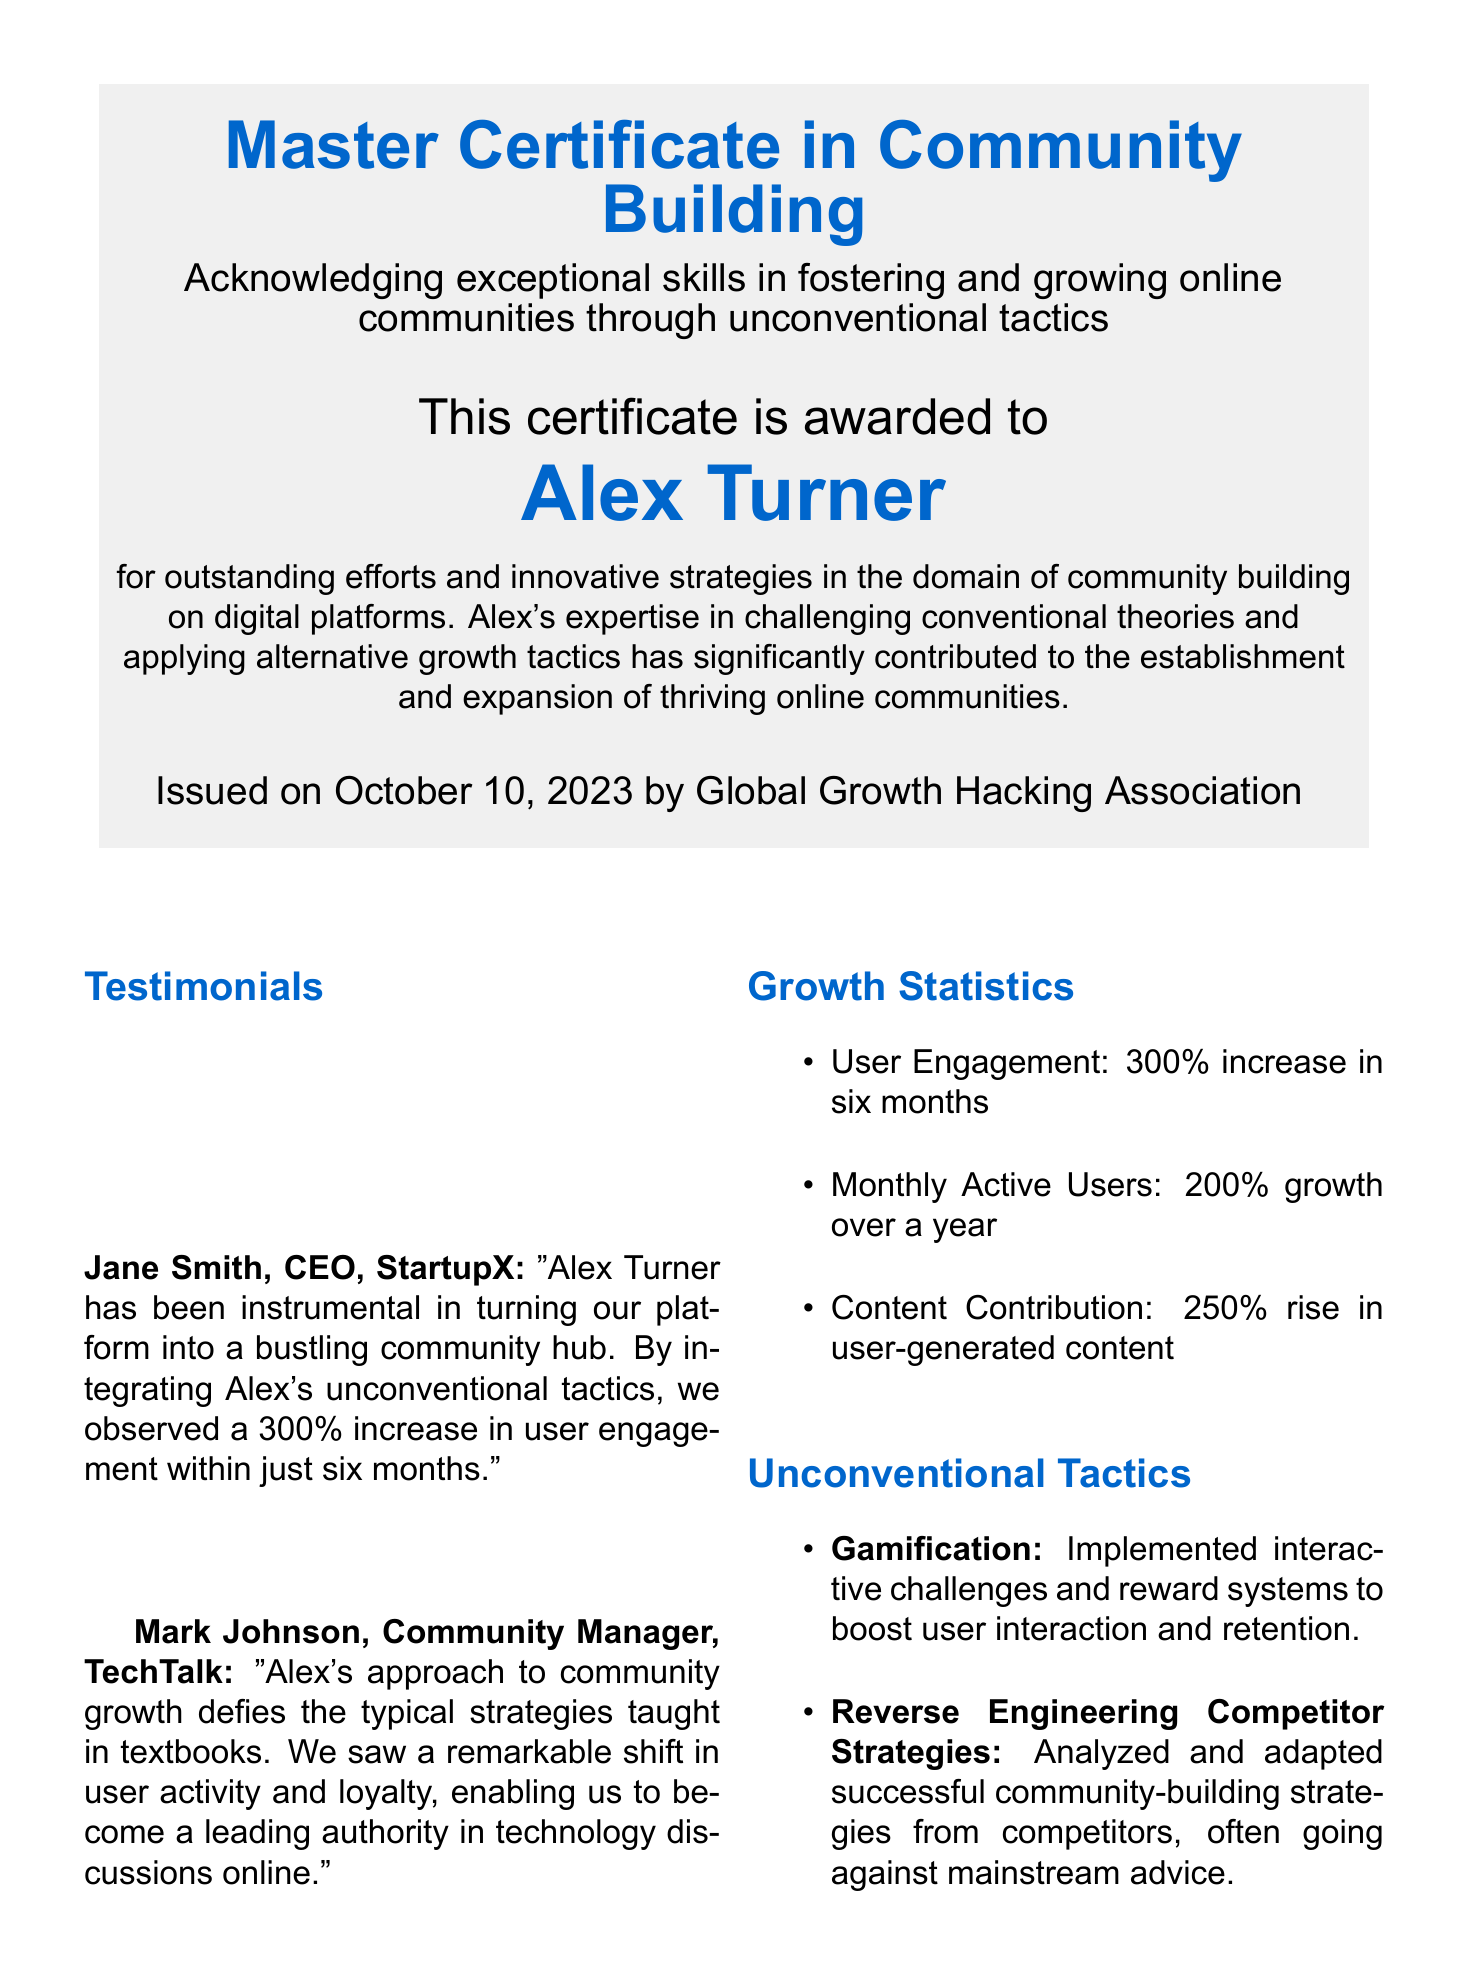What is the name of the certificate? The name of the certificate is prominently displayed at the top of the document.
Answer: Master Certificate in Community Building Who is the certificate awarded to? The recipient is named directly below the certificate title.
Answer: Alex Turner What date was the certificate issued? The issuance date is clearly stated at the bottom of the certificate.
Answer: October 10, 2023 What is the percentage increase in user engagement? The growth statistic indicates a specific increase in user engagement.
Answer: 300% Which company does Jane Smith represent? The testimonial section includes the name of the company associated with Jane Smith.
Answer: StartupX What tactic involved using interactive challenges? The unconventional tactics include several strategies, one of which involves challenges.
Answer: Gamification What percentage growth did the Monthly Active Users achieve over a year? This statistic is listed among the growth statistics in the document.
Answer: 200% Who issued the certificate? The organization that issued the certificate is mentioned at the bottom.
Answer: Global Growth Hacking Association 